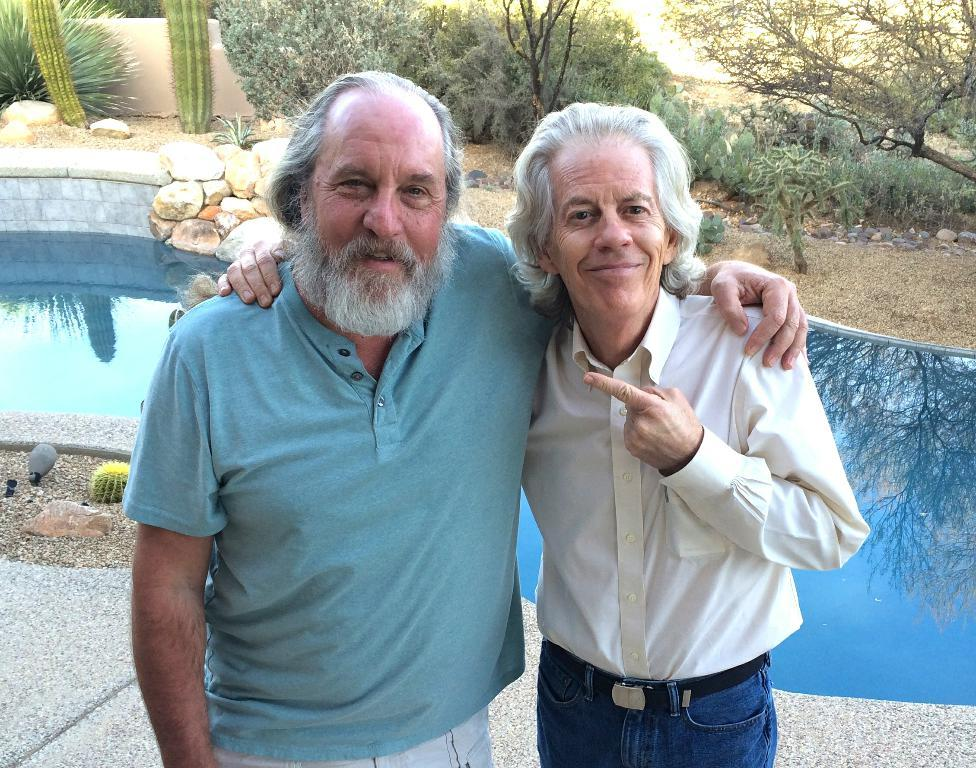How many old men are in the image? There are two old men in the image. What are the old men doing in the image? The old men are standing beside each other. What can be seen in the background of the image? There is a school, rocks, cactus plants, and other plants visible in the background of the image. What type of bag is the plant using to carry its seeds in the image? There is no plant or bag present in the image; it features two old men standing beside each other with a background that includes a school, rocks, cactus plants, and other plants. How many nails can be seen holding the old men's hats in the image? There are no nails or hats visible in the image; the old men are not wearing hats, and there are no nails present. 